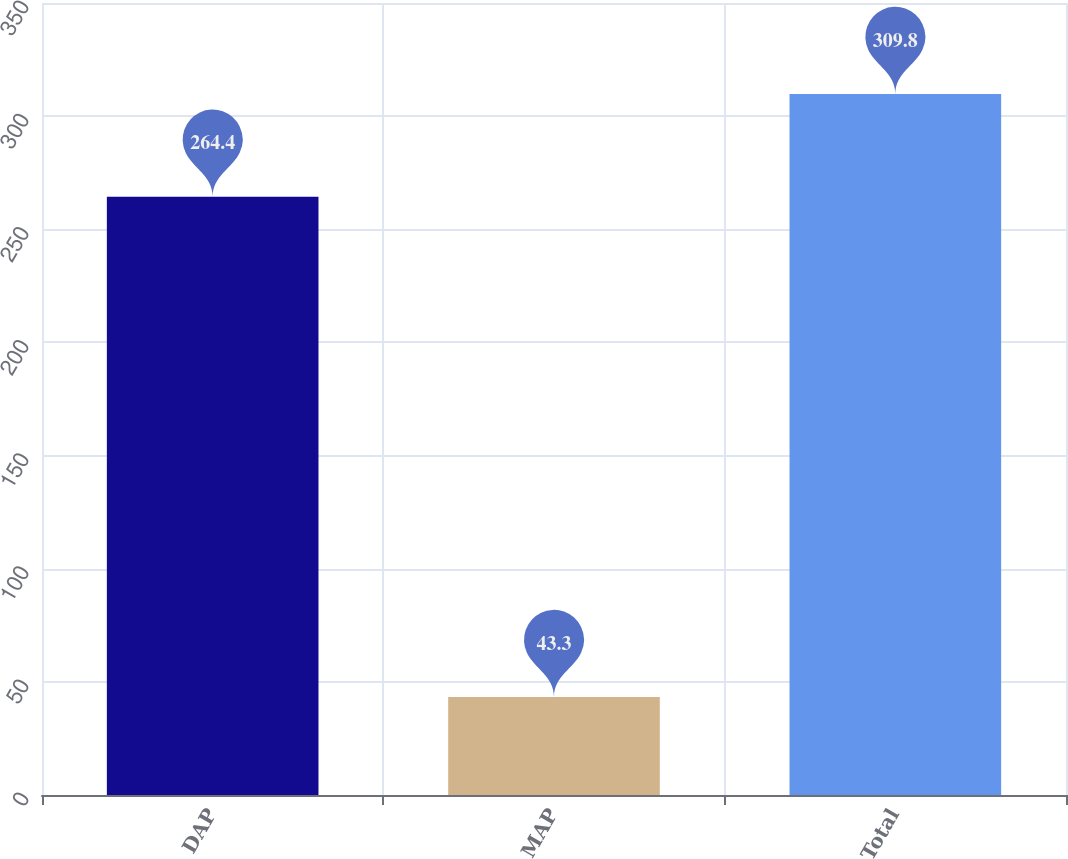<chart> <loc_0><loc_0><loc_500><loc_500><bar_chart><fcel>DAP<fcel>MAP<fcel>Total<nl><fcel>264.4<fcel>43.3<fcel>309.8<nl></chart> 